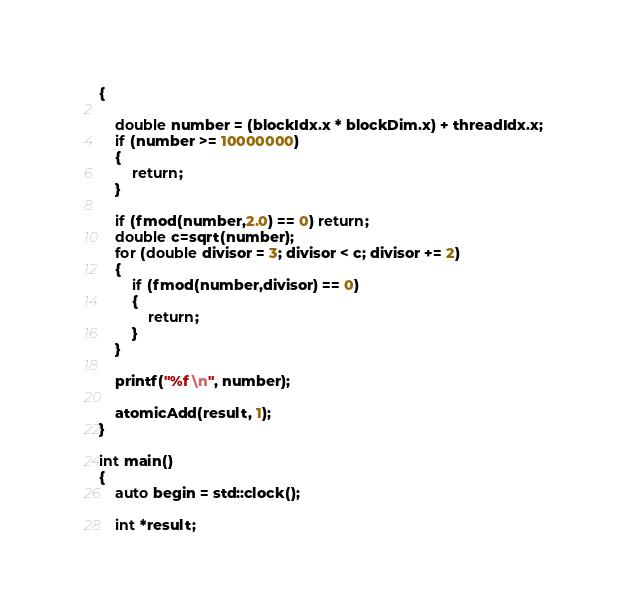Convert code to text. <code><loc_0><loc_0><loc_500><loc_500><_Cuda_>{

	double number = (blockIdx.x * blockDim.x) + threadIdx.x;
	if (number >= 10000000)
	{
		return;
	}

	if (fmod(number,2.0) == 0) return;
	double c=sqrt(number);
	for (double divisor = 3; divisor < c; divisor += 2)
	{
		if (fmod(number,divisor) == 0)
		{
			return;
		}
	}
	
	printf("%f \n", number);
	
	atomicAdd(result, 1);
}

int main()
{
	auto begin = std::clock();

	int *result;</code> 